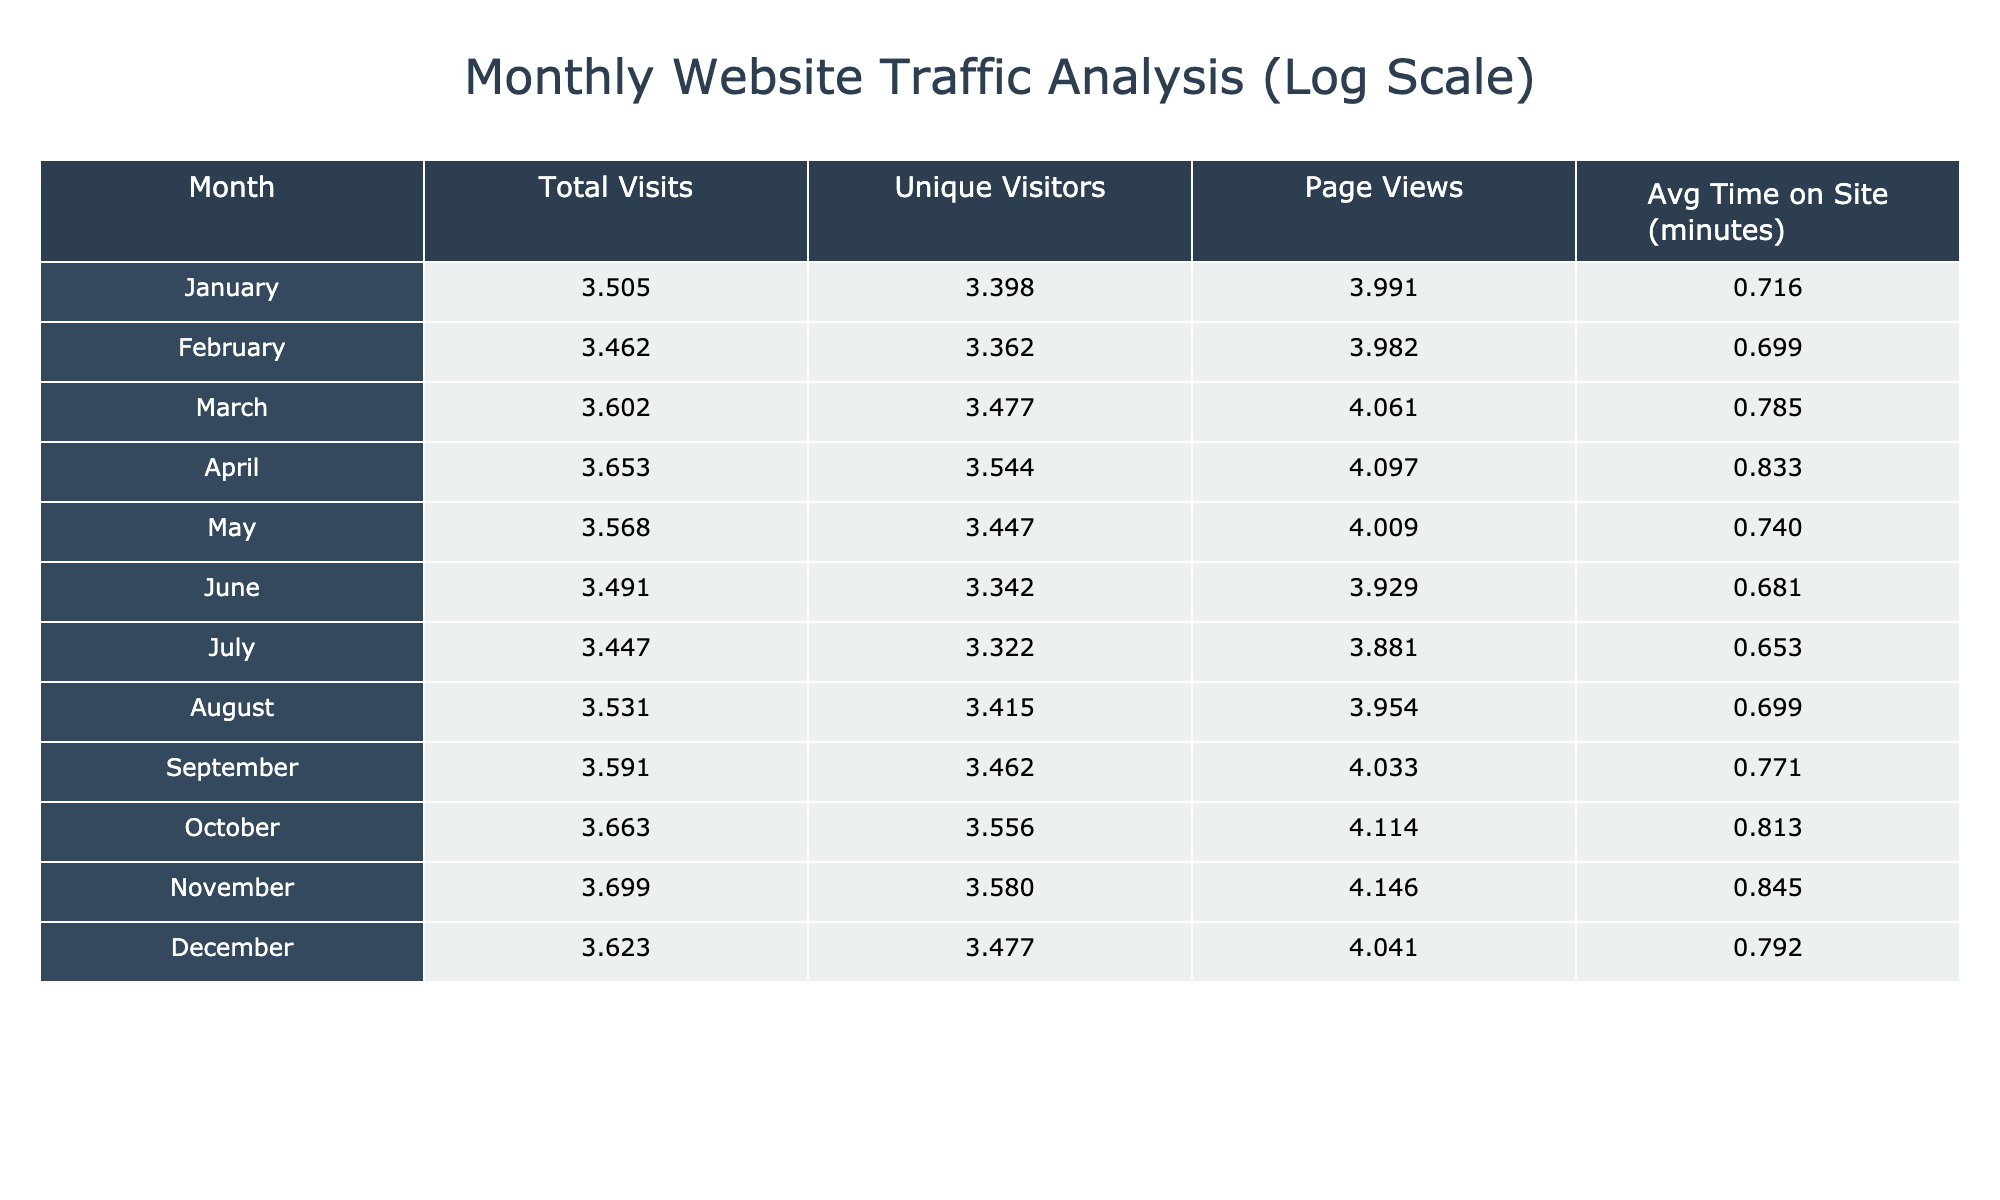what was the total number of visits in November? The table lists total visits for each month, where November shows 5,000.
Answer: 5000 which month had the highest number of unique visitors? By reviewing the unique visitors for each month, April has the highest number at 3,500.
Answer: 3500 what is the average number of page views from January to March? The page views for these months are 9,800 (January), 9,600 (February), and 11,500 (March). Summing these values gives 30,900. Then dividing by 3 leads to an average of 10,300.
Answer: 10300 is the average time on site in October greater than the average time on site in February? October shows an average time of 6.5 minutes while February shows 5.0 minutes. Since 6.5 is greater than 5.0, the statement is true.
Answer: Yes in which month did the total visits decrease compared to the previous month? By examining the total visits data, a decrease is noted in July (2,800) compared to June (3,100).
Answer: July what is the difference in total visits between November and April? November has 5,000 visits, and April has 4,500 visits. The difference is calculated as 5,000 - 4,500 = 500.
Answer: 500 which month displayed the lowest average time on site? Reviewing the average time on site, July has the lowest at 4.5 minutes.
Answer: 4.5 what was the total number of unique visitors from April to June? The unique visitors from April (3,500), May (2,800), and June (2,200) sum to 8,500.
Answer: 8500 how many total visits were recorded in the second half of the year (July to December)? The total visits from July (2,800), August (3,400), September (3,900), October (4,600), November (5,000), and December (4,200) add up to 24,900.
Answer: 24900 